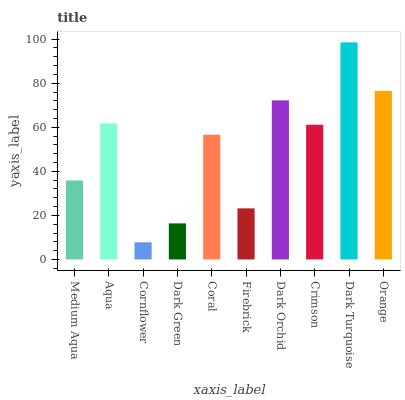Is Cornflower the minimum?
Answer yes or no. Yes. Is Dark Turquoise the maximum?
Answer yes or no. Yes. Is Aqua the minimum?
Answer yes or no. No. Is Aqua the maximum?
Answer yes or no. No. Is Aqua greater than Medium Aqua?
Answer yes or no. Yes. Is Medium Aqua less than Aqua?
Answer yes or no. Yes. Is Medium Aqua greater than Aqua?
Answer yes or no. No. Is Aqua less than Medium Aqua?
Answer yes or no. No. Is Crimson the high median?
Answer yes or no. Yes. Is Coral the low median?
Answer yes or no. Yes. Is Orange the high median?
Answer yes or no. No. Is Dark Orchid the low median?
Answer yes or no. No. 